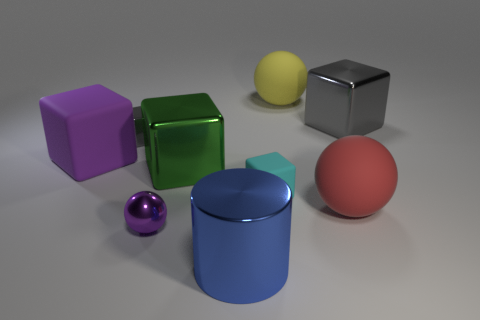Are there any shadows in the scene? If so, what can they tell us about the light source? Yes, there are shadows cast by each object, indicating the presence of a light source. The shadows are relatively soft and diffuse, suggesting the light source is not extremely close to the objects. The direction of the shadows, mainly towards the bottom right corner, implies that the light source is positioned towards the top left side of the scene. 